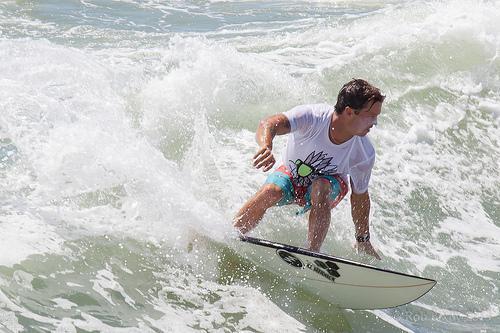How many men are there?
Give a very brief answer. 1. 